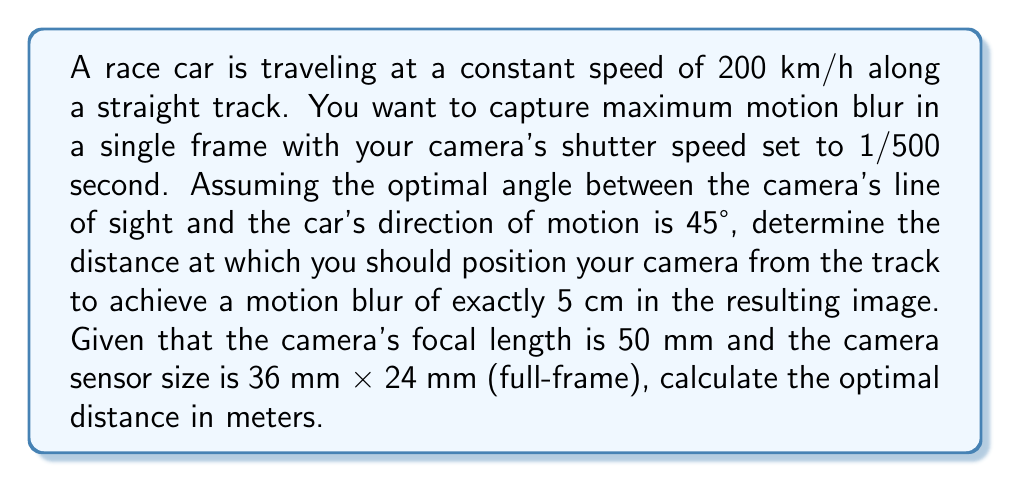Give your solution to this math problem. To solve this problem, we'll follow these steps:

1) First, let's convert the car's speed to m/s:
   $$ 200 \text{ km/h} = \frac{200 \times 1000}{3600} \text{ m/s} = 55.56 \text{ m/s} $$

2) During the exposure time (1/500 s), the car travels:
   $$ d = 55.56 \text{ m/s} \times \frac{1}{500} \text{ s} = 0.1111 \text{ m} $$

3) The component of this motion perpendicular to the camera's line of sight (at 45°) is:
   $$ d_{\perp} = 0.1111 \text{ m} \times \sin(45°) = 0.0786 \text{ m} $$

4) We want this to appear as 5 cm (0.05 m) in the image. The ratio between the real-world size and image size is the magnification (M):
   $$ M = \frac{0.05 \text{ m}}{0.0786 \text{ m}} = 0.636 $$

5) For a given focal length (f) and subject distance (D), the magnification is given by:
   $$ M = \frac{f}{D - f} $$

6) Substituting our known values and solving for D:
   $$ 0.636 = \frac{0.05 \text{ m}}{D - 0.05 \text{ m}} $$
   $$ D - 0.05 \text{ m} = \frac{0.05 \text{ m}}{0.636} $$
   $$ D = \frac{0.05 \text{ m}}{0.636} + 0.05 \text{ m} = 0.1286 \text{ m} $$

Therefore, the optimal distance to position the camera is approximately 0.1286 meters or 12.86 cm from the track.
Answer: 0.1286 m 